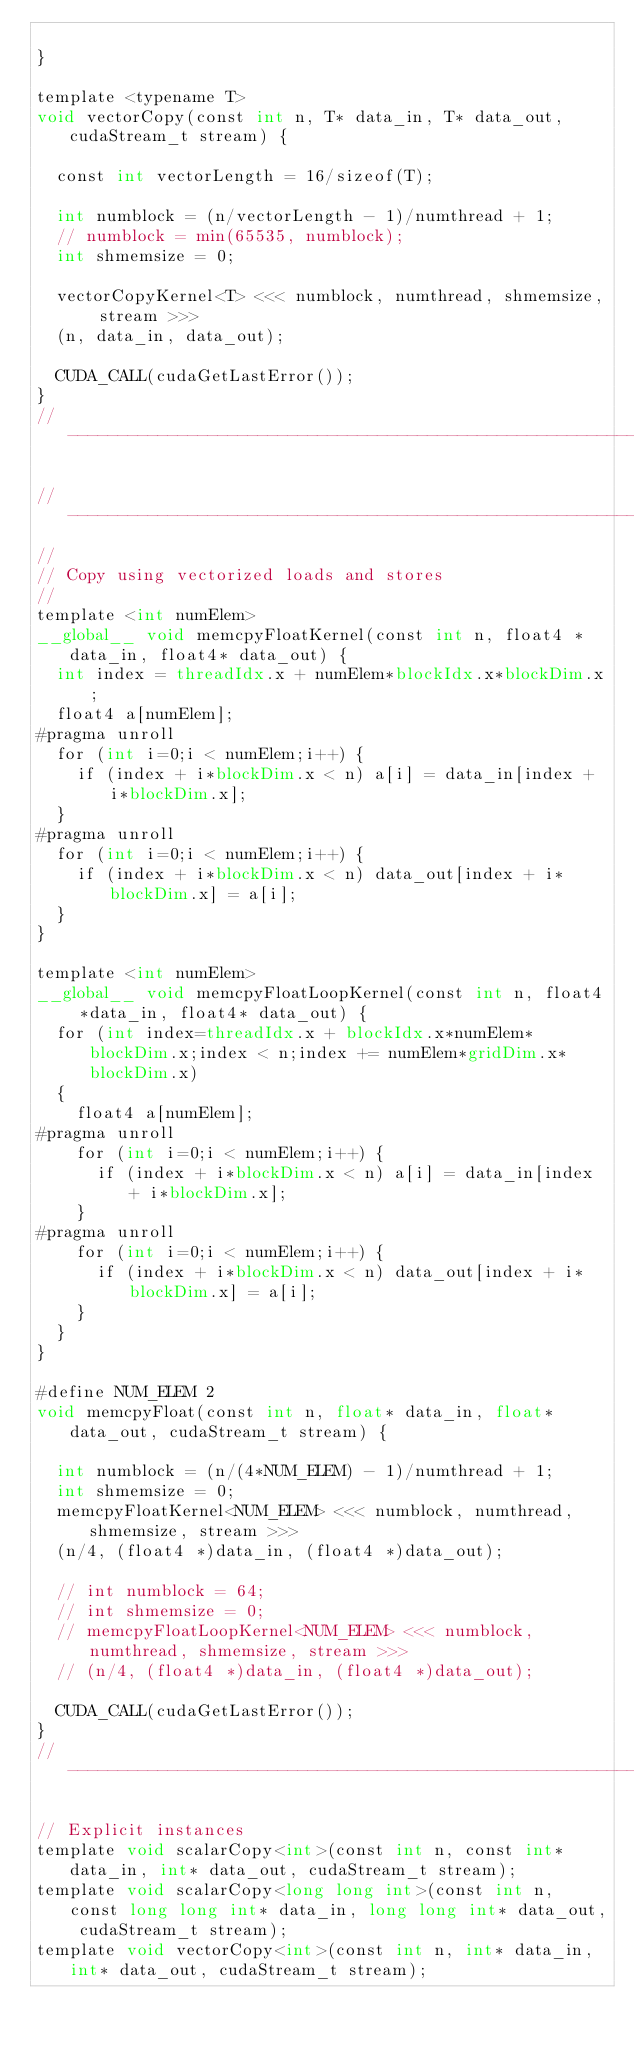Convert code to text. <code><loc_0><loc_0><loc_500><loc_500><_Cuda_>
}

template <typename T>
void vectorCopy(const int n, T* data_in, T* data_out, cudaStream_t stream) {

  const int vectorLength = 16/sizeof(T);

  int numblock = (n/vectorLength - 1)/numthread + 1;
  // numblock = min(65535, numblock);
  int shmemsize = 0;

  vectorCopyKernel<T> <<< numblock, numthread, shmemsize, stream >>>
  (n, data_in, data_out);

  CUDA_CALL(cudaGetLastError());
}
// -----------------------------------------------------------------------------------

// -----------------------------------------------------------------------------------
//
// Copy using vectorized loads and stores
//
template <int numElem>
__global__ void memcpyFloatKernel(const int n, float4 *data_in, float4* data_out) {
  int index = threadIdx.x + numElem*blockIdx.x*blockDim.x;
  float4 a[numElem];
#pragma unroll
  for (int i=0;i < numElem;i++) {
    if (index + i*blockDim.x < n) a[i] = data_in[index + i*blockDim.x];
  }
#pragma unroll
  for (int i=0;i < numElem;i++) {
    if (index + i*blockDim.x < n) data_out[index + i*blockDim.x] = a[i];
  }
}

template <int numElem>
__global__ void memcpyFloatLoopKernel(const int n, float4 *data_in, float4* data_out) {
  for (int index=threadIdx.x + blockIdx.x*numElem*blockDim.x;index < n;index += numElem*gridDim.x*blockDim.x)
  {
    float4 a[numElem];
#pragma unroll
    for (int i=0;i < numElem;i++) {
      if (index + i*blockDim.x < n) a[i] = data_in[index + i*blockDim.x];
    }
#pragma unroll
    for (int i=0;i < numElem;i++) {
      if (index + i*blockDim.x < n) data_out[index + i*blockDim.x] = a[i];
    }
  }
}

#define NUM_ELEM 2
void memcpyFloat(const int n, float* data_in, float* data_out, cudaStream_t stream) {

  int numblock = (n/(4*NUM_ELEM) - 1)/numthread + 1;
  int shmemsize = 0;
  memcpyFloatKernel<NUM_ELEM> <<< numblock, numthread, shmemsize, stream >>>
  (n/4, (float4 *)data_in, (float4 *)data_out);

  // int numblock = 64;
  // int shmemsize = 0;
  // memcpyFloatLoopKernel<NUM_ELEM> <<< numblock, numthread, shmemsize, stream >>>
  // (n/4, (float4 *)data_in, (float4 *)data_out);

  CUDA_CALL(cudaGetLastError());
}
// -----------------------------------------------------------------------------------

// Explicit instances
template void scalarCopy<int>(const int n, const int* data_in, int* data_out, cudaStream_t stream);
template void scalarCopy<long long int>(const int n, const long long int* data_in, long long int* data_out, cudaStream_t stream);
template void vectorCopy<int>(const int n, int* data_in, int* data_out, cudaStream_t stream);</code> 